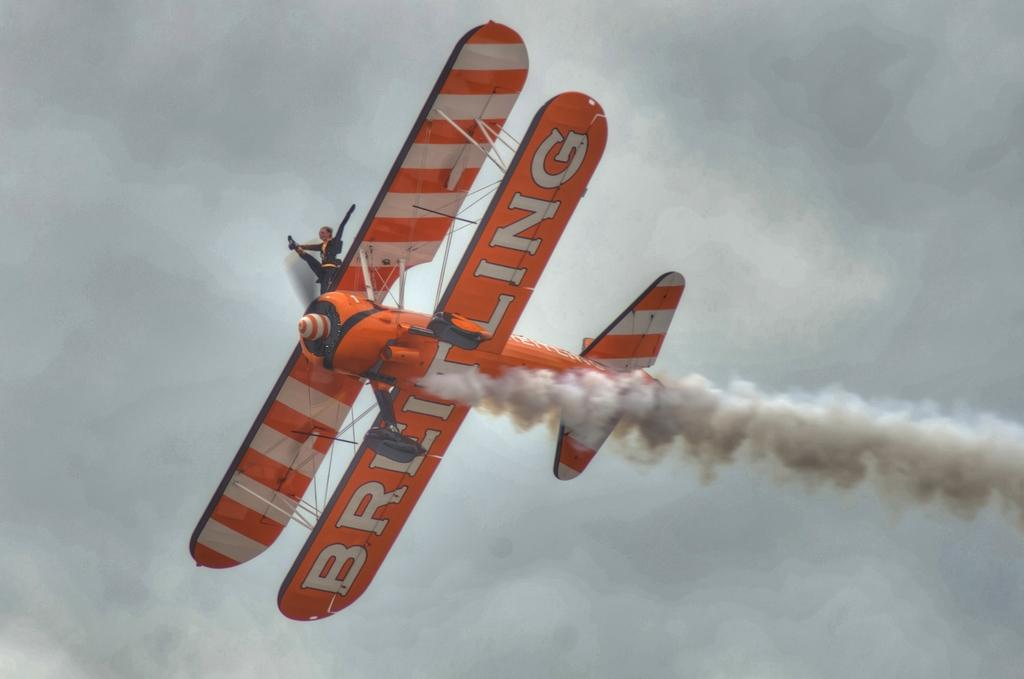<image>
Describe the image concisely. A daredevil performs a trick on top of a prop airplane. 